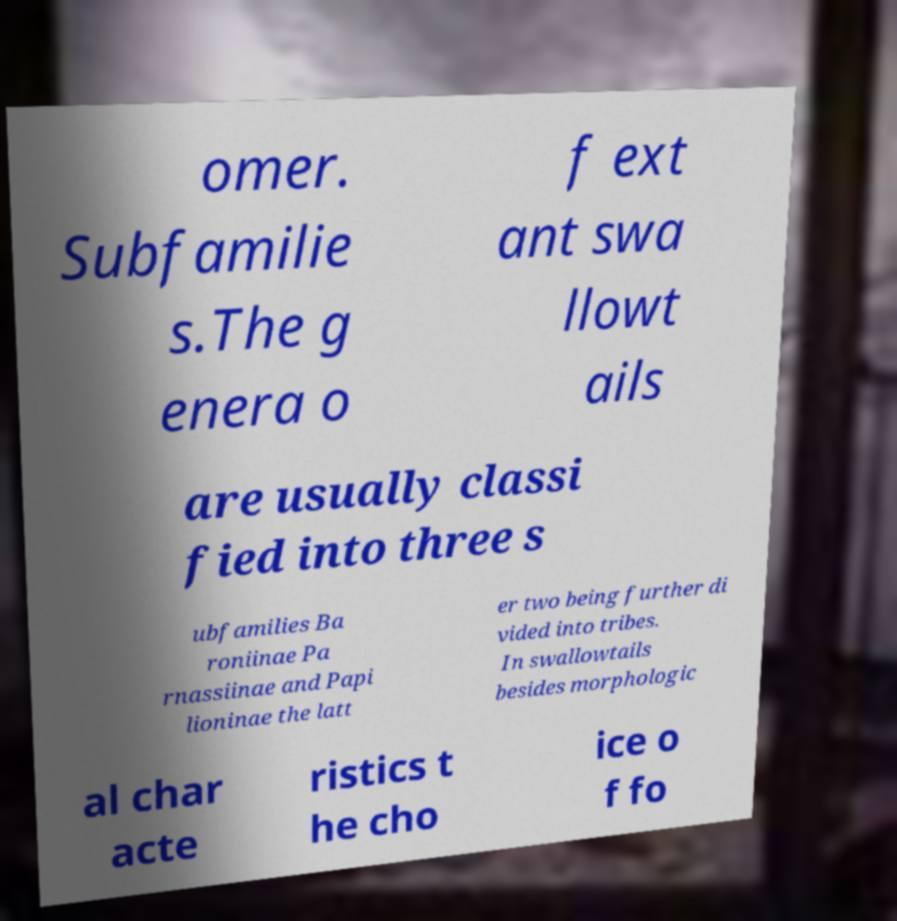Please read and relay the text visible in this image. What does it say? omer. Subfamilie s.The g enera o f ext ant swa llowt ails are usually classi fied into three s ubfamilies Ba roniinae Pa rnassiinae and Papi lioninae the latt er two being further di vided into tribes. In swallowtails besides morphologic al char acte ristics t he cho ice o f fo 